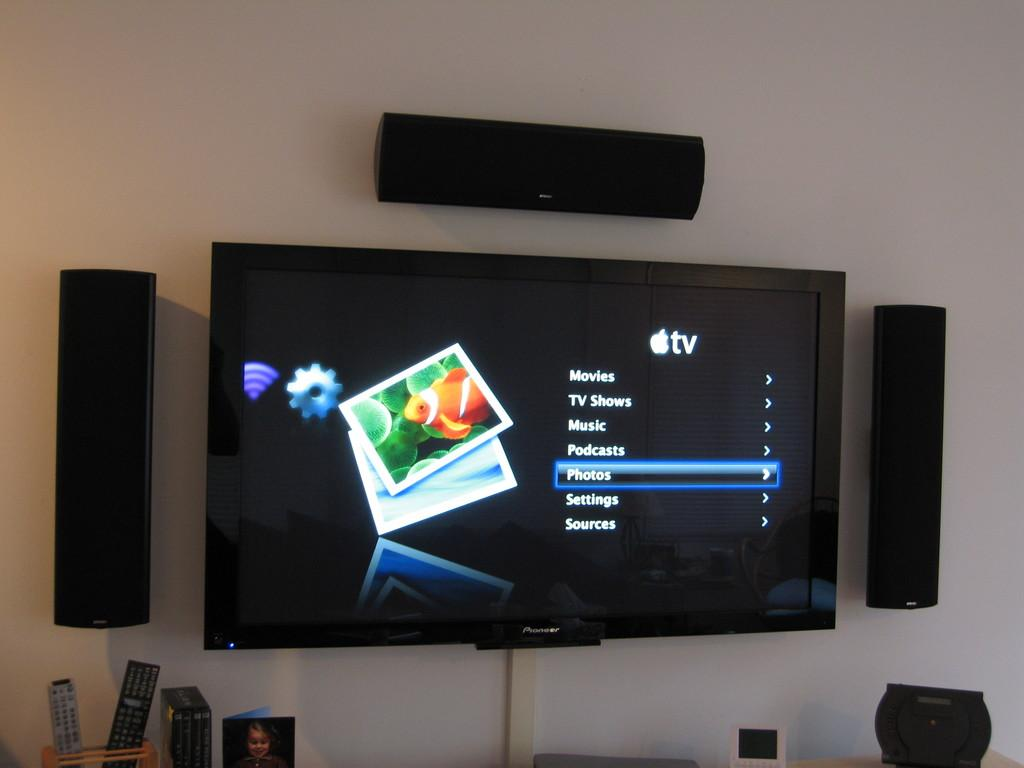<image>
Relay a brief, clear account of the picture shown. the letters tv on the top of a screen 